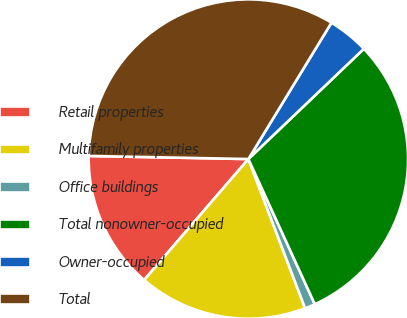Convert chart to OTSL. <chart><loc_0><loc_0><loc_500><loc_500><pie_chart><fcel>Retail properties<fcel>Multifamily properties<fcel>Office buildings<fcel>Total nonowner-occupied<fcel>Owner-occupied<fcel>Total<nl><fcel>13.99%<fcel>17.1%<fcel>1.05%<fcel>30.3%<fcel>4.16%<fcel>33.4%<nl></chart> 